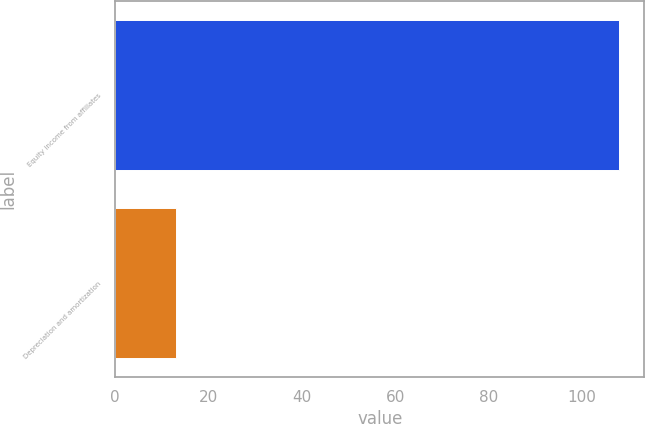Convert chart. <chart><loc_0><loc_0><loc_500><loc_500><bar_chart><fcel>Equity income from affiliates<fcel>Depreciation and amortization<nl><fcel>108<fcel>13<nl></chart> 